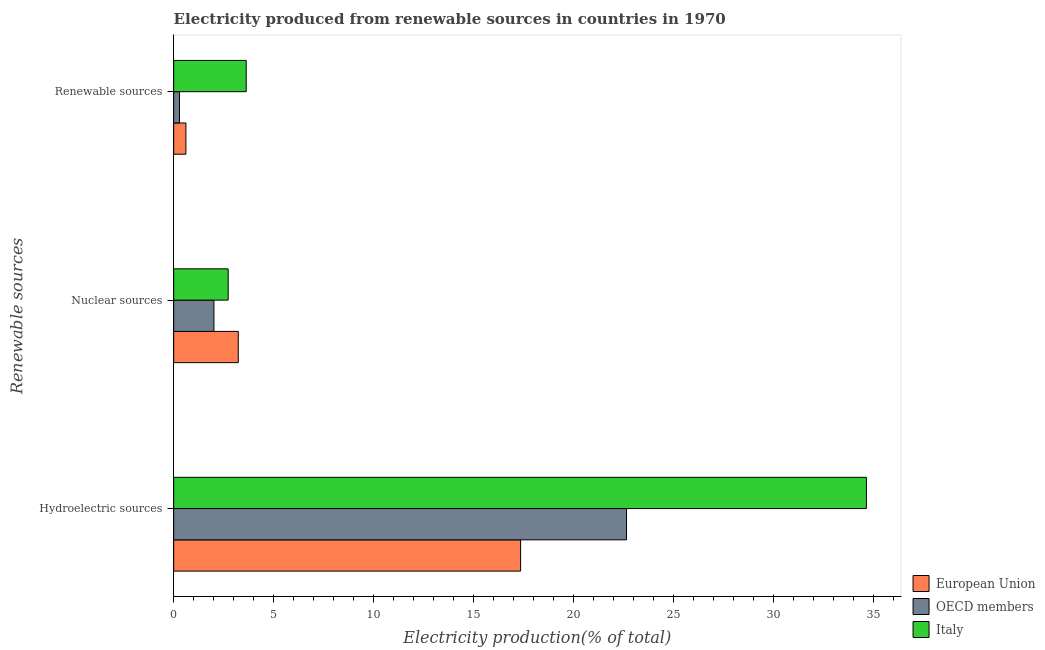How many different coloured bars are there?
Ensure brevity in your answer.  3. How many groups of bars are there?
Provide a succinct answer. 3. Are the number of bars per tick equal to the number of legend labels?
Your answer should be compact. Yes. How many bars are there on the 3rd tick from the bottom?
Make the answer very short. 3. What is the label of the 1st group of bars from the top?
Your answer should be very brief. Renewable sources. What is the percentage of electricity produced by nuclear sources in European Union?
Ensure brevity in your answer.  3.23. Across all countries, what is the maximum percentage of electricity produced by hydroelectric sources?
Provide a succinct answer. 34.66. Across all countries, what is the minimum percentage of electricity produced by hydroelectric sources?
Provide a short and direct response. 17.36. In which country was the percentage of electricity produced by nuclear sources maximum?
Give a very brief answer. European Union. In which country was the percentage of electricity produced by hydroelectric sources minimum?
Provide a succinct answer. European Union. What is the total percentage of electricity produced by hydroelectric sources in the graph?
Keep it short and to the point. 74.67. What is the difference between the percentage of electricity produced by renewable sources in European Union and that in Italy?
Your answer should be very brief. -3.02. What is the difference between the percentage of electricity produced by hydroelectric sources in European Union and the percentage of electricity produced by nuclear sources in Italy?
Ensure brevity in your answer.  14.63. What is the average percentage of electricity produced by renewable sources per country?
Offer a terse response. 1.51. What is the difference between the percentage of electricity produced by hydroelectric sources and percentage of electricity produced by renewable sources in OECD members?
Your answer should be compact. 22.36. In how many countries, is the percentage of electricity produced by hydroelectric sources greater than 3 %?
Offer a terse response. 3. What is the ratio of the percentage of electricity produced by hydroelectric sources in European Union to that in Italy?
Keep it short and to the point. 0.5. What is the difference between the highest and the second highest percentage of electricity produced by hydroelectric sources?
Make the answer very short. 12. What is the difference between the highest and the lowest percentage of electricity produced by renewable sources?
Offer a very short reply. 3.34. In how many countries, is the percentage of electricity produced by hydroelectric sources greater than the average percentage of electricity produced by hydroelectric sources taken over all countries?
Your response must be concise. 1. Is the sum of the percentage of electricity produced by nuclear sources in Italy and European Union greater than the maximum percentage of electricity produced by hydroelectric sources across all countries?
Your response must be concise. No. What does the 3rd bar from the top in Nuclear sources represents?
Make the answer very short. European Union. What does the 3rd bar from the bottom in Renewable sources represents?
Provide a short and direct response. Italy. How many bars are there?
Offer a terse response. 9. How many countries are there in the graph?
Offer a terse response. 3. What is the difference between two consecutive major ticks on the X-axis?
Provide a short and direct response. 5. How many legend labels are there?
Make the answer very short. 3. How are the legend labels stacked?
Give a very brief answer. Vertical. What is the title of the graph?
Offer a terse response. Electricity produced from renewable sources in countries in 1970. What is the label or title of the X-axis?
Your answer should be very brief. Electricity production(% of total). What is the label or title of the Y-axis?
Your answer should be compact. Renewable sources. What is the Electricity production(% of total) in European Union in Hydroelectric sources?
Make the answer very short. 17.36. What is the Electricity production(% of total) in OECD members in Hydroelectric sources?
Give a very brief answer. 22.65. What is the Electricity production(% of total) of Italy in Hydroelectric sources?
Ensure brevity in your answer.  34.66. What is the Electricity production(% of total) of European Union in Nuclear sources?
Your answer should be very brief. 3.23. What is the Electricity production(% of total) in OECD members in Nuclear sources?
Your response must be concise. 2.01. What is the Electricity production(% of total) in Italy in Nuclear sources?
Offer a terse response. 2.73. What is the Electricity production(% of total) of European Union in Renewable sources?
Provide a short and direct response. 0.61. What is the Electricity production(% of total) of OECD members in Renewable sources?
Your response must be concise. 0.29. What is the Electricity production(% of total) of Italy in Renewable sources?
Your response must be concise. 3.63. Across all Renewable sources, what is the maximum Electricity production(% of total) of European Union?
Ensure brevity in your answer.  17.36. Across all Renewable sources, what is the maximum Electricity production(% of total) in OECD members?
Your answer should be very brief. 22.65. Across all Renewable sources, what is the maximum Electricity production(% of total) of Italy?
Your response must be concise. 34.66. Across all Renewable sources, what is the minimum Electricity production(% of total) of European Union?
Provide a succinct answer. 0.61. Across all Renewable sources, what is the minimum Electricity production(% of total) in OECD members?
Make the answer very short. 0.29. Across all Renewable sources, what is the minimum Electricity production(% of total) in Italy?
Make the answer very short. 2.73. What is the total Electricity production(% of total) of European Union in the graph?
Keep it short and to the point. 21.2. What is the total Electricity production(% of total) in OECD members in the graph?
Offer a very short reply. 24.96. What is the total Electricity production(% of total) in Italy in the graph?
Provide a short and direct response. 41.01. What is the difference between the Electricity production(% of total) in European Union in Hydroelectric sources and that in Nuclear sources?
Your answer should be very brief. 14.12. What is the difference between the Electricity production(% of total) of OECD members in Hydroelectric sources and that in Nuclear sources?
Offer a very short reply. 20.64. What is the difference between the Electricity production(% of total) in Italy in Hydroelectric sources and that in Nuclear sources?
Offer a very short reply. 31.93. What is the difference between the Electricity production(% of total) in European Union in Hydroelectric sources and that in Renewable sources?
Provide a succinct answer. 16.74. What is the difference between the Electricity production(% of total) of OECD members in Hydroelectric sources and that in Renewable sources?
Offer a very short reply. 22.36. What is the difference between the Electricity production(% of total) in Italy in Hydroelectric sources and that in Renewable sources?
Your response must be concise. 31.03. What is the difference between the Electricity production(% of total) of European Union in Nuclear sources and that in Renewable sources?
Keep it short and to the point. 2.62. What is the difference between the Electricity production(% of total) of OECD members in Nuclear sources and that in Renewable sources?
Keep it short and to the point. 1.72. What is the difference between the Electricity production(% of total) of Italy in Nuclear sources and that in Renewable sources?
Give a very brief answer. -0.9. What is the difference between the Electricity production(% of total) in European Union in Hydroelectric sources and the Electricity production(% of total) in OECD members in Nuclear sources?
Your answer should be compact. 15.34. What is the difference between the Electricity production(% of total) of European Union in Hydroelectric sources and the Electricity production(% of total) of Italy in Nuclear sources?
Keep it short and to the point. 14.63. What is the difference between the Electricity production(% of total) in OECD members in Hydroelectric sources and the Electricity production(% of total) in Italy in Nuclear sources?
Offer a very short reply. 19.93. What is the difference between the Electricity production(% of total) of European Union in Hydroelectric sources and the Electricity production(% of total) of OECD members in Renewable sources?
Ensure brevity in your answer.  17.07. What is the difference between the Electricity production(% of total) in European Union in Hydroelectric sources and the Electricity production(% of total) in Italy in Renewable sources?
Your answer should be compact. 13.73. What is the difference between the Electricity production(% of total) of OECD members in Hydroelectric sources and the Electricity production(% of total) of Italy in Renewable sources?
Make the answer very short. 19.03. What is the difference between the Electricity production(% of total) of European Union in Nuclear sources and the Electricity production(% of total) of OECD members in Renewable sources?
Offer a terse response. 2.94. What is the difference between the Electricity production(% of total) of European Union in Nuclear sources and the Electricity production(% of total) of Italy in Renewable sources?
Your response must be concise. -0.4. What is the difference between the Electricity production(% of total) in OECD members in Nuclear sources and the Electricity production(% of total) in Italy in Renewable sources?
Keep it short and to the point. -1.62. What is the average Electricity production(% of total) in European Union per Renewable sources?
Your response must be concise. 7.07. What is the average Electricity production(% of total) of OECD members per Renewable sources?
Make the answer very short. 8.32. What is the average Electricity production(% of total) of Italy per Renewable sources?
Make the answer very short. 13.67. What is the difference between the Electricity production(% of total) of European Union and Electricity production(% of total) of OECD members in Hydroelectric sources?
Keep it short and to the point. -5.3. What is the difference between the Electricity production(% of total) in European Union and Electricity production(% of total) in Italy in Hydroelectric sources?
Your response must be concise. -17.3. What is the difference between the Electricity production(% of total) of OECD members and Electricity production(% of total) of Italy in Hydroelectric sources?
Your response must be concise. -12. What is the difference between the Electricity production(% of total) in European Union and Electricity production(% of total) in OECD members in Nuclear sources?
Your answer should be very brief. 1.22. What is the difference between the Electricity production(% of total) in European Union and Electricity production(% of total) in Italy in Nuclear sources?
Provide a succinct answer. 0.51. What is the difference between the Electricity production(% of total) in OECD members and Electricity production(% of total) in Italy in Nuclear sources?
Offer a very short reply. -0.71. What is the difference between the Electricity production(% of total) of European Union and Electricity production(% of total) of OECD members in Renewable sources?
Provide a succinct answer. 0.32. What is the difference between the Electricity production(% of total) in European Union and Electricity production(% of total) in Italy in Renewable sources?
Your answer should be very brief. -3.02. What is the difference between the Electricity production(% of total) of OECD members and Electricity production(% of total) of Italy in Renewable sources?
Make the answer very short. -3.34. What is the ratio of the Electricity production(% of total) of European Union in Hydroelectric sources to that in Nuclear sources?
Provide a succinct answer. 5.37. What is the ratio of the Electricity production(% of total) in OECD members in Hydroelectric sources to that in Nuclear sources?
Your response must be concise. 11.25. What is the ratio of the Electricity production(% of total) of Italy in Hydroelectric sources to that in Nuclear sources?
Offer a very short reply. 12.71. What is the ratio of the Electricity production(% of total) in European Union in Hydroelectric sources to that in Renewable sources?
Your answer should be very brief. 28.38. What is the ratio of the Electricity production(% of total) in OECD members in Hydroelectric sources to that in Renewable sources?
Give a very brief answer. 77.84. What is the ratio of the Electricity production(% of total) in Italy in Hydroelectric sources to that in Renewable sources?
Keep it short and to the point. 9.55. What is the ratio of the Electricity production(% of total) in European Union in Nuclear sources to that in Renewable sources?
Provide a succinct answer. 5.29. What is the ratio of the Electricity production(% of total) in OECD members in Nuclear sources to that in Renewable sources?
Your answer should be very brief. 6.92. What is the ratio of the Electricity production(% of total) in Italy in Nuclear sources to that in Renewable sources?
Make the answer very short. 0.75. What is the difference between the highest and the second highest Electricity production(% of total) in European Union?
Offer a very short reply. 14.12. What is the difference between the highest and the second highest Electricity production(% of total) of OECD members?
Ensure brevity in your answer.  20.64. What is the difference between the highest and the second highest Electricity production(% of total) in Italy?
Give a very brief answer. 31.03. What is the difference between the highest and the lowest Electricity production(% of total) in European Union?
Give a very brief answer. 16.74. What is the difference between the highest and the lowest Electricity production(% of total) of OECD members?
Your answer should be very brief. 22.36. What is the difference between the highest and the lowest Electricity production(% of total) of Italy?
Provide a succinct answer. 31.93. 